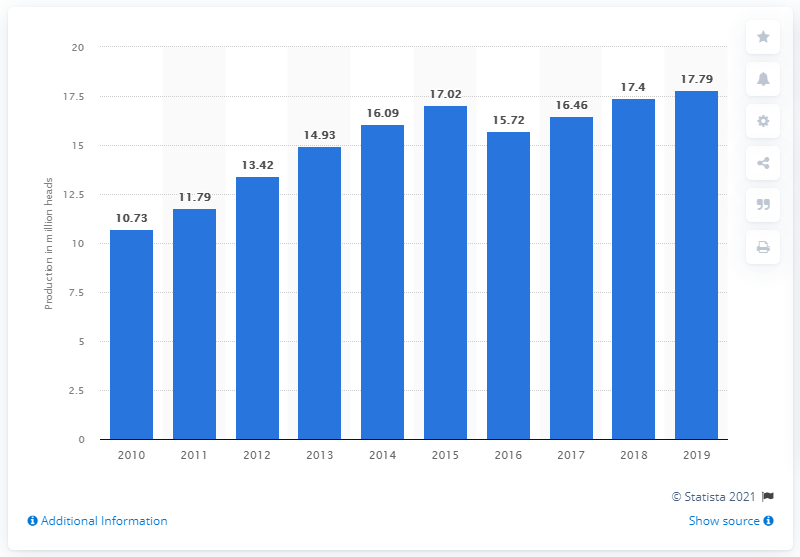Draw attention to some important aspects in this diagram. In 2019, a total of 17,790 sheep were produced in Indonesia. 